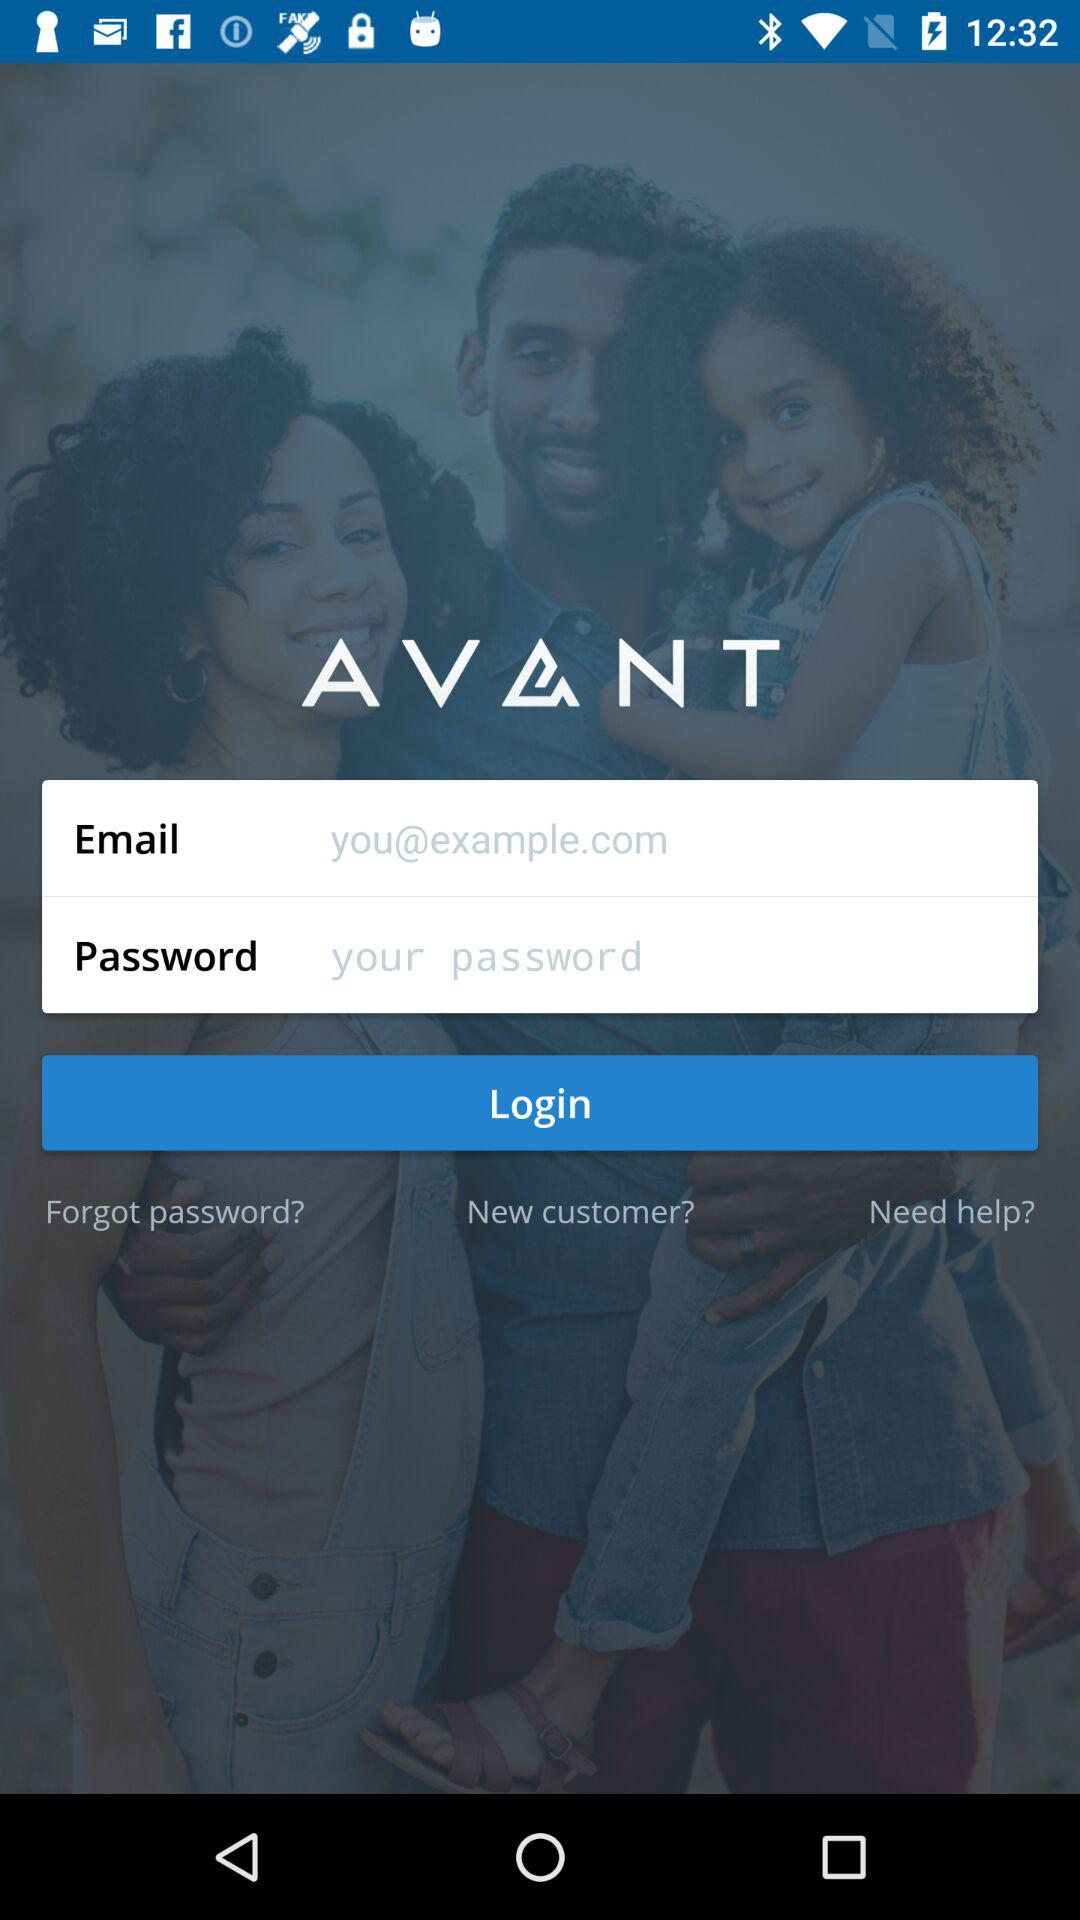What is the name of the application? The name of the application is "Avant - Mobile Banking". 